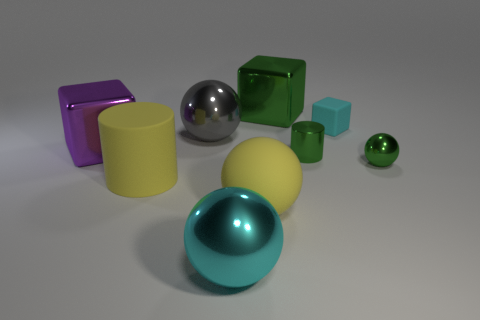There is a cyan metal ball; is it the same size as the block that is in front of the cyan block?
Give a very brief answer. Yes. What is the color of the big metal cube that is in front of the green metal cube?
Provide a succinct answer. Purple. How many yellow things are either spheres or large shiny spheres?
Provide a short and direct response. 1. What is the color of the small sphere?
Provide a succinct answer. Green. Are there fewer matte spheres in front of the green metal ball than green metal things that are left of the cyan cube?
Make the answer very short. Yes. What shape is the matte object that is both on the left side of the green cube and right of the yellow matte cylinder?
Your answer should be very brief. Sphere. How many metallic objects have the same shape as the small cyan rubber object?
Offer a terse response. 2. What size is the cylinder that is the same material as the tiny green ball?
Provide a short and direct response. Small. What number of rubber balls have the same size as the purple metallic cube?
Your answer should be very brief. 1. What size is the metallic cylinder that is the same color as the tiny metal ball?
Give a very brief answer. Small. 